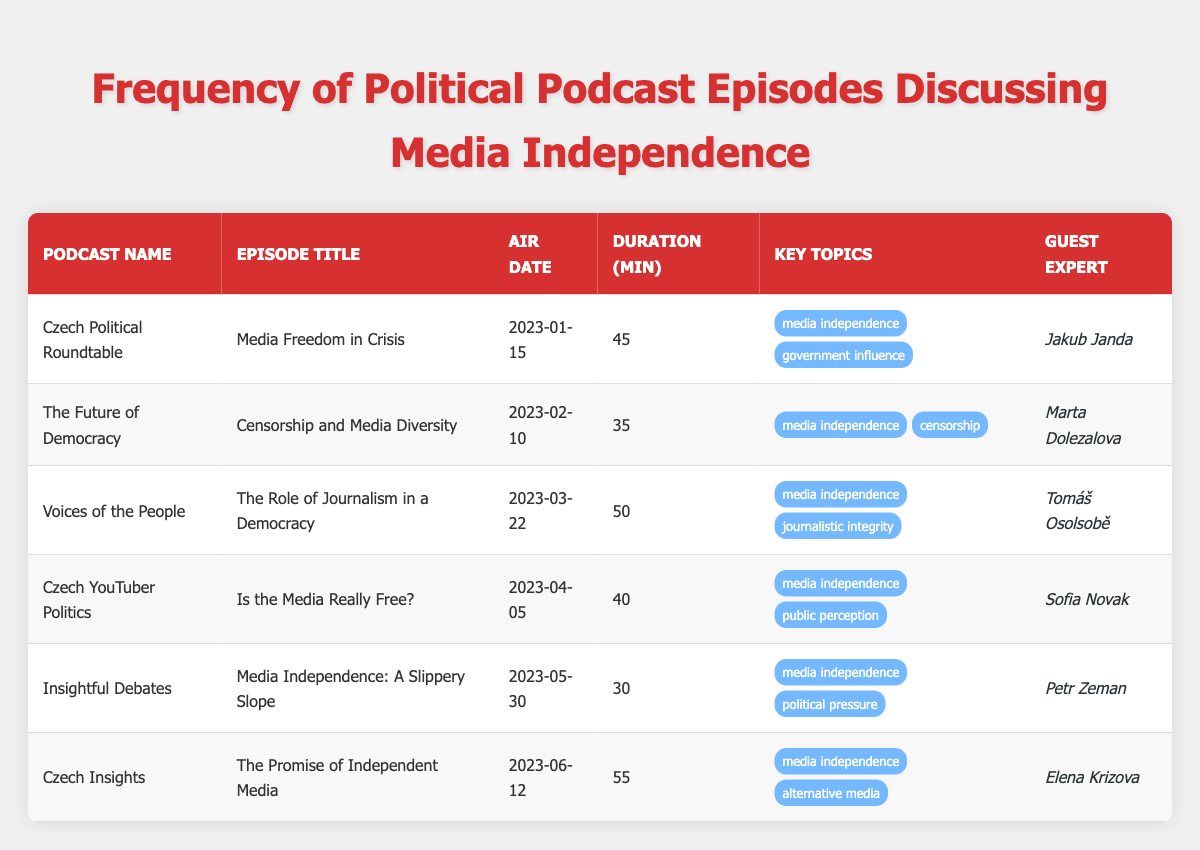What is the title of the episode that discusses "Media Freedom in Crisis"? By looking at the table, the first row for the podcast "Czech Political Roundtable" shows the episode title "Media Freedom in Crisis".
Answer: Media Freedom in Crisis Which podcast aired an episode about censorship on February 10, 2023? The table shows that "The Future of Democracy" aired the episode titled "Censorship and Media Diversity" on that date.
Answer: The Future of Democracy How many minutes of discussion does the episode "The Promise of Independent Media" last? In the table, the entry for "Czech Insights" shows that this episode has a discussion duration of 55 minutes.
Answer: 55 minutes What is the total discussion time of all episodes discussing media independence? To find this, we need to sum the durations of all episodes that mention "media independence". The durations are 45, 35, 50, 40, 30, and 55 minutes. Adding these gives 45 + 35 + 50 + 40 + 30 + 55 = 255 minutes.
Answer: 255 minutes Did the episode titled "Is the Media Really Free?" discuss government influence? Referring to the table, this episode from "Czech YouTuber Politics" lists "public perception" as a key topic and does not mention "government influence", making the statement false.
Answer: No Which guest expert appeared most frequently in episodes discussing media independence? The table shows that each episode features different guest experts, with no repetitions among the listed podcasts. Hence, there is no guest expert appearing multiple times within the provided data.
Answer: None How many episodes discussed media independence in relation to journalistic integrity? In the table, we see that there is only one episode titled "The Role of Journalism in a Democracy" that mentions "journalistic integrity" as a key topic, indicating this is the sole episode.
Answer: 1 episode What is the average duration in minutes of episodes discussing media independence? To calculate the average, we take the total duration of 255 minutes from the previous question and divide it by the 6 episodes that discuss media independence. Therefore, the average is 255 / 6 = 42.5 minutes.
Answer: 42.5 minutes Which podcast had the shortest episode discussing media independence? By analyzing the durations in the table, the "Insightful Debates" episode has the shortest duration of 30 minutes among those discussing media independence.
Answer: Insightful Debates 